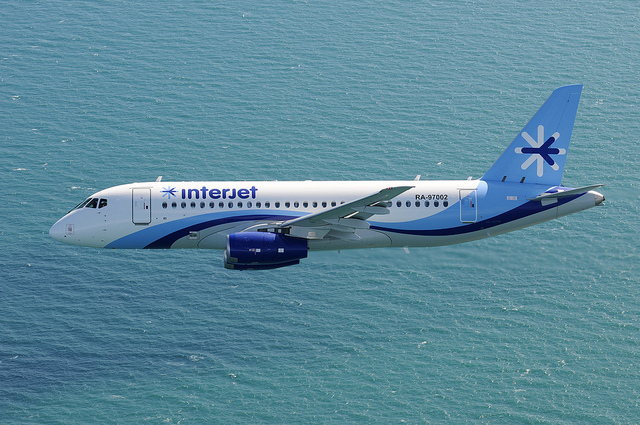Read and extract the text from this image. interjet RA 97002 